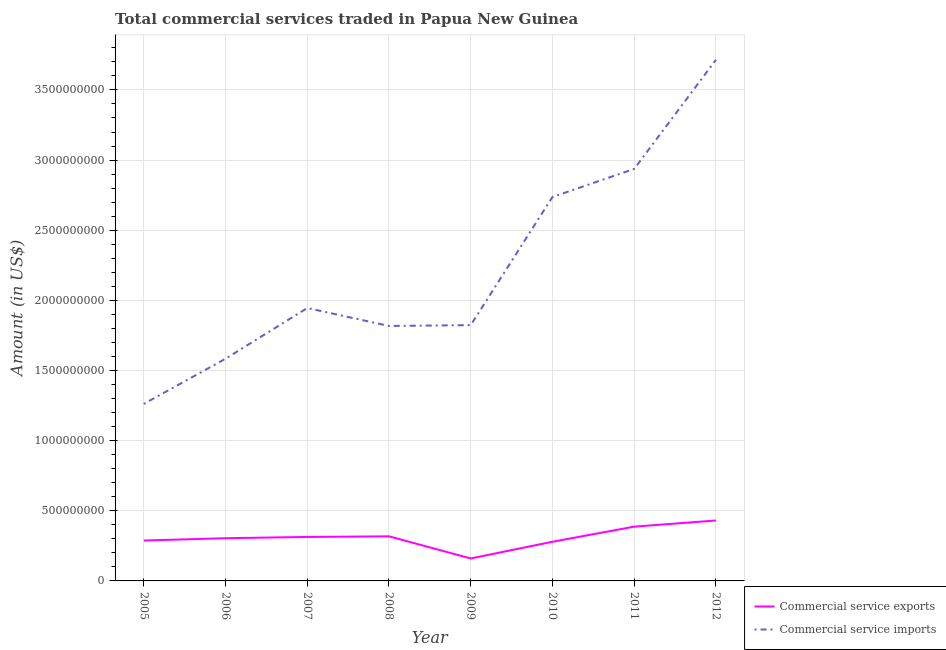How many different coloured lines are there?
Offer a terse response. 2. Does the line corresponding to amount of commercial service exports intersect with the line corresponding to amount of commercial service imports?
Offer a terse response. No. Is the number of lines equal to the number of legend labels?
Give a very brief answer. Yes. What is the amount of commercial service imports in 2006?
Your answer should be compact. 1.58e+09. Across all years, what is the maximum amount of commercial service exports?
Make the answer very short. 4.31e+08. Across all years, what is the minimum amount of commercial service exports?
Offer a terse response. 1.60e+08. In which year was the amount of commercial service imports maximum?
Provide a succinct answer. 2012. What is the total amount of commercial service exports in the graph?
Make the answer very short. 2.48e+09. What is the difference between the amount of commercial service exports in 2005 and that in 2010?
Make the answer very short. 8.80e+06. What is the difference between the amount of commercial service exports in 2012 and the amount of commercial service imports in 2009?
Your answer should be compact. -1.39e+09. What is the average amount of commercial service exports per year?
Your answer should be compact. 3.10e+08. In the year 2011, what is the difference between the amount of commercial service imports and amount of commercial service exports?
Keep it short and to the point. 2.55e+09. What is the ratio of the amount of commercial service imports in 2009 to that in 2010?
Make the answer very short. 0.67. Is the difference between the amount of commercial service exports in 2006 and 2007 greater than the difference between the amount of commercial service imports in 2006 and 2007?
Provide a short and direct response. Yes. What is the difference between the highest and the second highest amount of commercial service imports?
Keep it short and to the point. 7.78e+08. What is the difference between the highest and the lowest amount of commercial service imports?
Your answer should be very brief. 2.45e+09. In how many years, is the amount of commercial service exports greater than the average amount of commercial service exports taken over all years?
Your answer should be compact. 4. Is the sum of the amount of commercial service imports in 2006 and 2007 greater than the maximum amount of commercial service exports across all years?
Your answer should be very brief. Yes. Does the amount of commercial service exports monotonically increase over the years?
Your answer should be very brief. No. Is the amount of commercial service exports strictly greater than the amount of commercial service imports over the years?
Provide a succinct answer. No. How many years are there in the graph?
Your response must be concise. 8. What is the difference between two consecutive major ticks on the Y-axis?
Offer a terse response. 5.00e+08. Are the values on the major ticks of Y-axis written in scientific E-notation?
Offer a very short reply. No. How many legend labels are there?
Provide a succinct answer. 2. What is the title of the graph?
Provide a short and direct response. Total commercial services traded in Papua New Guinea. What is the label or title of the Y-axis?
Offer a terse response. Amount (in US$). What is the Amount (in US$) in Commercial service exports in 2005?
Provide a succinct answer. 2.88e+08. What is the Amount (in US$) in Commercial service imports in 2005?
Offer a terse response. 1.26e+09. What is the Amount (in US$) of Commercial service exports in 2006?
Your answer should be very brief. 3.05e+08. What is the Amount (in US$) in Commercial service imports in 2006?
Offer a very short reply. 1.58e+09. What is the Amount (in US$) of Commercial service exports in 2007?
Your answer should be compact. 3.13e+08. What is the Amount (in US$) in Commercial service imports in 2007?
Your answer should be compact. 1.95e+09. What is the Amount (in US$) in Commercial service exports in 2008?
Provide a succinct answer. 3.18e+08. What is the Amount (in US$) in Commercial service imports in 2008?
Make the answer very short. 1.82e+09. What is the Amount (in US$) in Commercial service exports in 2009?
Offer a very short reply. 1.60e+08. What is the Amount (in US$) in Commercial service imports in 2009?
Offer a terse response. 1.82e+09. What is the Amount (in US$) of Commercial service exports in 2010?
Your response must be concise. 2.79e+08. What is the Amount (in US$) in Commercial service imports in 2010?
Give a very brief answer. 2.74e+09. What is the Amount (in US$) of Commercial service exports in 2011?
Your answer should be very brief. 3.87e+08. What is the Amount (in US$) in Commercial service imports in 2011?
Your response must be concise. 2.94e+09. What is the Amount (in US$) in Commercial service exports in 2012?
Provide a succinct answer. 4.31e+08. What is the Amount (in US$) in Commercial service imports in 2012?
Your answer should be very brief. 3.71e+09. Across all years, what is the maximum Amount (in US$) of Commercial service exports?
Offer a very short reply. 4.31e+08. Across all years, what is the maximum Amount (in US$) of Commercial service imports?
Keep it short and to the point. 3.71e+09. Across all years, what is the minimum Amount (in US$) in Commercial service exports?
Keep it short and to the point. 1.60e+08. Across all years, what is the minimum Amount (in US$) in Commercial service imports?
Make the answer very short. 1.26e+09. What is the total Amount (in US$) of Commercial service exports in the graph?
Keep it short and to the point. 2.48e+09. What is the total Amount (in US$) in Commercial service imports in the graph?
Provide a short and direct response. 1.78e+1. What is the difference between the Amount (in US$) of Commercial service exports in 2005 and that in 2006?
Make the answer very short. -1.66e+07. What is the difference between the Amount (in US$) in Commercial service imports in 2005 and that in 2006?
Provide a succinct answer. -3.22e+08. What is the difference between the Amount (in US$) of Commercial service exports in 2005 and that in 2007?
Provide a short and direct response. -2.55e+07. What is the difference between the Amount (in US$) in Commercial service imports in 2005 and that in 2007?
Offer a terse response. -6.83e+08. What is the difference between the Amount (in US$) in Commercial service exports in 2005 and that in 2008?
Keep it short and to the point. -3.00e+07. What is the difference between the Amount (in US$) in Commercial service imports in 2005 and that in 2008?
Give a very brief answer. -5.56e+08. What is the difference between the Amount (in US$) of Commercial service exports in 2005 and that in 2009?
Your response must be concise. 1.28e+08. What is the difference between the Amount (in US$) of Commercial service imports in 2005 and that in 2009?
Make the answer very short. -5.62e+08. What is the difference between the Amount (in US$) in Commercial service exports in 2005 and that in 2010?
Provide a succinct answer. 8.80e+06. What is the difference between the Amount (in US$) of Commercial service imports in 2005 and that in 2010?
Provide a succinct answer. -1.48e+09. What is the difference between the Amount (in US$) of Commercial service exports in 2005 and that in 2011?
Offer a very short reply. -9.90e+07. What is the difference between the Amount (in US$) in Commercial service imports in 2005 and that in 2011?
Your answer should be compact. -1.68e+09. What is the difference between the Amount (in US$) in Commercial service exports in 2005 and that in 2012?
Give a very brief answer. -1.43e+08. What is the difference between the Amount (in US$) in Commercial service imports in 2005 and that in 2012?
Offer a very short reply. -2.45e+09. What is the difference between the Amount (in US$) in Commercial service exports in 2006 and that in 2007?
Offer a terse response. -8.85e+06. What is the difference between the Amount (in US$) of Commercial service imports in 2006 and that in 2007?
Keep it short and to the point. -3.61e+08. What is the difference between the Amount (in US$) of Commercial service exports in 2006 and that in 2008?
Offer a very short reply. -1.34e+07. What is the difference between the Amount (in US$) of Commercial service imports in 2006 and that in 2008?
Keep it short and to the point. -2.34e+08. What is the difference between the Amount (in US$) of Commercial service exports in 2006 and that in 2009?
Provide a succinct answer. 1.44e+08. What is the difference between the Amount (in US$) in Commercial service imports in 2006 and that in 2009?
Offer a very short reply. -2.40e+08. What is the difference between the Amount (in US$) of Commercial service exports in 2006 and that in 2010?
Offer a very short reply. 2.54e+07. What is the difference between the Amount (in US$) in Commercial service imports in 2006 and that in 2010?
Your answer should be very brief. -1.15e+09. What is the difference between the Amount (in US$) in Commercial service exports in 2006 and that in 2011?
Give a very brief answer. -8.23e+07. What is the difference between the Amount (in US$) in Commercial service imports in 2006 and that in 2011?
Give a very brief answer. -1.35e+09. What is the difference between the Amount (in US$) of Commercial service exports in 2006 and that in 2012?
Your response must be concise. -1.26e+08. What is the difference between the Amount (in US$) of Commercial service imports in 2006 and that in 2012?
Offer a terse response. -2.13e+09. What is the difference between the Amount (in US$) of Commercial service exports in 2007 and that in 2008?
Offer a terse response. -4.53e+06. What is the difference between the Amount (in US$) in Commercial service imports in 2007 and that in 2008?
Provide a succinct answer. 1.28e+08. What is the difference between the Amount (in US$) of Commercial service exports in 2007 and that in 2009?
Ensure brevity in your answer.  1.53e+08. What is the difference between the Amount (in US$) in Commercial service imports in 2007 and that in 2009?
Your answer should be compact. 1.22e+08. What is the difference between the Amount (in US$) in Commercial service exports in 2007 and that in 2010?
Provide a succinct answer. 3.43e+07. What is the difference between the Amount (in US$) of Commercial service imports in 2007 and that in 2010?
Your answer should be compact. -7.92e+08. What is the difference between the Amount (in US$) of Commercial service exports in 2007 and that in 2011?
Your answer should be very brief. -7.35e+07. What is the difference between the Amount (in US$) in Commercial service imports in 2007 and that in 2011?
Provide a succinct answer. -9.92e+08. What is the difference between the Amount (in US$) in Commercial service exports in 2007 and that in 2012?
Your answer should be compact. -1.17e+08. What is the difference between the Amount (in US$) of Commercial service imports in 2007 and that in 2012?
Provide a short and direct response. -1.77e+09. What is the difference between the Amount (in US$) of Commercial service exports in 2008 and that in 2009?
Make the answer very short. 1.58e+08. What is the difference between the Amount (in US$) of Commercial service imports in 2008 and that in 2009?
Ensure brevity in your answer.  -5.82e+06. What is the difference between the Amount (in US$) of Commercial service exports in 2008 and that in 2010?
Offer a terse response. 3.88e+07. What is the difference between the Amount (in US$) in Commercial service imports in 2008 and that in 2010?
Provide a succinct answer. -9.19e+08. What is the difference between the Amount (in US$) of Commercial service exports in 2008 and that in 2011?
Provide a succinct answer. -6.90e+07. What is the difference between the Amount (in US$) of Commercial service imports in 2008 and that in 2011?
Your response must be concise. -1.12e+09. What is the difference between the Amount (in US$) of Commercial service exports in 2008 and that in 2012?
Offer a terse response. -1.13e+08. What is the difference between the Amount (in US$) of Commercial service imports in 2008 and that in 2012?
Provide a short and direct response. -1.90e+09. What is the difference between the Amount (in US$) of Commercial service exports in 2009 and that in 2010?
Keep it short and to the point. -1.19e+08. What is the difference between the Amount (in US$) of Commercial service imports in 2009 and that in 2010?
Make the answer very short. -9.14e+08. What is the difference between the Amount (in US$) of Commercial service exports in 2009 and that in 2011?
Provide a short and direct response. -2.27e+08. What is the difference between the Amount (in US$) of Commercial service imports in 2009 and that in 2011?
Ensure brevity in your answer.  -1.11e+09. What is the difference between the Amount (in US$) of Commercial service exports in 2009 and that in 2012?
Keep it short and to the point. -2.71e+08. What is the difference between the Amount (in US$) in Commercial service imports in 2009 and that in 2012?
Provide a short and direct response. -1.89e+09. What is the difference between the Amount (in US$) of Commercial service exports in 2010 and that in 2011?
Your answer should be very brief. -1.08e+08. What is the difference between the Amount (in US$) of Commercial service imports in 2010 and that in 2011?
Provide a succinct answer. -2.00e+08. What is the difference between the Amount (in US$) in Commercial service exports in 2010 and that in 2012?
Provide a short and direct response. -1.52e+08. What is the difference between the Amount (in US$) of Commercial service imports in 2010 and that in 2012?
Offer a terse response. -9.78e+08. What is the difference between the Amount (in US$) in Commercial service exports in 2011 and that in 2012?
Your answer should be very brief. -4.38e+07. What is the difference between the Amount (in US$) of Commercial service imports in 2011 and that in 2012?
Offer a very short reply. -7.78e+08. What is the difference between the Amount (in US$) of Commercial service exports in 2005 and the Amount (in US$) of Commercial service imports in 2006?
Ensure brevity in your answer.  -1.30e+09. What is the difference between the Amount (in US$) in Commercial service exports in 2005 and the Amount (in US$) in Commercial service imports in 2007?
Your answer should be compact. -1.66e+09. What is the difference between the Amount (in US$) in Commercial service exports in 2005 and the Amount (in US$) in Commercial service imports in 2008?
Provide a short and direct response. -1.53e+09. What is the difference between the Amount (in US$) in Commercial service exports in 2005 and the Amount (in US$) in Commercial service imports in 2009?
Your response must be concise. -1.54e+09. What is the difference between the Amount (in US$) in Commercial service exports in 2005 and the Amount (in US$) in Commercial service imports in 2010?
Give a very brief answer. -2.45e+09. What is the difference between the Amount (in US$) in Commercial service exports in 2005 and the Amount (in US$) in Commercial service imports in 2011?
Your answer should be compact. -2.65e+09. What is the difference between the Amount (in US$) in Commercial service exports in 2005 and the Amount (in US$) in Commercial service imports in 2012?
Keep it short and to the point. -3.43e+09. What is the difference between the Amount (in US$) of Commercial service exports in 2006 and the Amount (in US$) of Commercial service imports in 2007?
Ensure brevity in your answer.  -1.64e+09. What is the difference between the Amount (in US$) of Commercial service exports in 2006 and the Amount (in US$) of Commercial service imports in 2008?
Keep it short and to the point. -1.51e+09. What is the difference between the Amount (in US$) in Commercial service exports in 2006 and the Amount (in US$) in Commercial service imports in 2009?
Your answer should be compact. -1.52e+09. What is the difference between the Amount (in US$) of Commercial service exports in 2006 and the Amount (in US$) of Commercial service imports in 2010?
Your answer should be very brief. -2.43e+09. What is the difference between the Amount (in US$) of Commercial service exports in 2006 and the Amount (in US$) of Commercial service imports in 2011?
Your answer should be very brief. -2.63e+09. What is the difference between the Amount (in US$) of Commercial service exports in 2006 and the Amount (in US$) of Commercial service imports in 2012?
Your answer should be compact. -3.41e+09. What is the difference between the Amount (in US$) of Commercial service exports in 2007 and the Amount (in US$) of Commercial service imports in 2008?
Provide a short and direct response. -1.50e+09. What is the difference between the Amount (in US$) in Commercial service exports in 2007 and the Amount (in US$) in Commercial service imports in 2009?
Make the answer very short. -1.51e+09. What is the difference between the Amount (in US$) in Commercial service exports in 2007 and the Amount (in US$) in Commercial service imports in 2010?
Ensure brevity in your answer.  -2.42e+09. What is the difference between the Amount (in US$) in Commercial service exports in 2007 and the Amount (in US$) in Commercial service imports in 2011?
Keep it short and to the point. -2.62e+09. What is the difference between the Amount (in US$) of Commercial service exports in 2007 and the Amount (in US$) of Commercial service imports in 2012?
Give a very brief answer. -3.40e+09. What is the difference between the Amount (in US$) in Commercial service exports in 2008 and the Amount (in US$) in Commercial service imports in 2009?
Ensure brevity in your answer.  -1.51e+09. What is the difference between the Amount (in US$) in Commercial service exports in 2008 and the Amount (in US$) in Commercial service imports in 2010?
Your answer should be very brief. -2.42e+09. What is the difference between the Amount (in US$) of Commercial service exports in 2008 and the Amount (in US$) of Commercial service imports in 2011?
Provide a succinct answer. -2.62e+09. What is the difference between the Amount (in US$) of Commercial service exports in 2008 and the Amount (in US$) of Commercial service imports in 2012?
Ensure brevity in your answer.  -3.40e+09. What is the difference between the Amount (in US$) of Commercial service exports in 2009 and the Amount (in US$) of Commercial service imports in 2010?
Your response must be concise. -2.58e+09. What is the difference between the Amount (in US$) in Commercial service exports in 2009 and the Amount (in US$) in Commercial service imports in 2011?
Your answer should be compact. -2.78e+09. What is the difference between the Amount (in US$) of Commercial service exports in 2009 and the Amount (in US$) of Commercial service imports in 2012?
Give a very brief answer. -3.55e+09. What is the difference between the Amount (in US$) of Commercial service exports in 2010 and the Amount (in US$) of Commercial service imports in 2011?
Provide a short and direct response. -2.66e+09. What is the difference between the Amount (in US$) in Commercial service exports in 2010 and the Amount (in US$) in Commercial service imports in 2012?
Provide a succinct answer. -3.44e+09. What is the difference between the Amount (in US$) of Commercial service exports in 2011 and the Amount (in US$) of Commercial service imports in 2012?
Give a very brief answer. -3.33e+09. What is the average Amount (in US$) of Commercial service exports per year?
Offer a very short reply. 3.10e+08. What is the average Amount (in US$) in Commercial service imports per year?
Offer a terse response. 2.23e+09. In the year 2005, what is the difference between the Amount (in US$) in Commercial service exports and Amount (in US$) in Commercial service imports?
Provide a succinct answer. -9.74e+08. In the year 2006, what is the difference between the Amount (in US$) of Commercial service exports and Amount (in US$) of Commercial service imports?
Ensure brevity in your answer.  -1.28e+09. In the year 2007, what is the difference between the Amount (in US$) in Commercial service exports and Amount (in US$) in Commercial service imports?
Ensure brevity in your answer.  -1.63e+09. In the year 2008, what is the difference between the Amount (in US$) of Commercial service exports and Amount (in US$) of Commercial service imports?
Give a very brief answer. -1.50e+09. In the year 2009, what is the difference between the Amount (in US$) in Commercial service exports and Amount (in US$) in Commercial service imports?
Your response must be concise. -1.66e+09. In the year 2010, what is the difference between the Amount (in US$) in Commercial service exports and Amount (in US$) in Commercial service imports?
Make the answer very short. -2.46e+09. In the year 2011, what is the difference between the Amount (in US$) in Commercial service exports and Amount (in US$) in Commercial service imports?
Keep it short and to the point. -2.55e+09. In the year 2012, what is the difference between the Amount (in US$) in Commercial service exports and Amount (in US$) in Commercial service imports?
Keep it short and to the point. -3.28e+09. What is the ratio of the Amount (in US$) of Commercial service exports in 2005 to that in 2006?
Give a very brief answer. 0.95. What is the ratio of the Amount (in US$) in Commercial service imports in 2005 to that in 2006?
Your answer should be very brief. 0.8. What is the ratio of the Amount (in US$) in Commercial service exports in 2005 to that in 2007?
Offer a terse response. 0.92. What is the ratio of the Amount (in US$) of Commercial service imports in 2005 to that in 2007?
Make the answer very short. 0.65. What is the ratio of the Amount (in US$) in Commercial service exports in 2005 to that in 2008?
Your answer should be very brief. 0.91. What is the ratio of the Amount (in US$) in Commercial service imports in 2005 to that in 2008?
Your answer should be compact. 0.69. What is the ratio of the Amount (in US$) in Commercial service exports in 2005 to that in 2009?
Give a very brief answer. 1.8. What is the ratio of the Amount (in US$) of Commercial service imports in 2005 to that in 2009?
Your answer should be very brief. 0.69. What is the ratio of the Amount (in US$) in Commercial service exports in 2005 to that in 2010?
Make the answer very short. 1.03. What is the ratio of the Amount (in US$) in Commercial service imports in 2005 to that in 2010?
Ensure brevity in your answer.  0.46. What is the ratio of the Amount (in US$) in Commercial service exports in 2005 to that in 2011?
Make the answer very short. 0.74. What is the ratio of the Amount (in US$) in Commercial service imports in 2005 to that in 2011?
Provide a short and direct response. 0.43. What is the ratio of the Amount (in US$) of Commercial service exports in 2005 to that in 2012?
Your answer should be very brief. 0.67. What is the ratio of the Amount (in US$) of Commercial service imports in 2005 to that in 2012?
Give a very brief answer. 0.34. What is the ratio of the Amount (in US$) in Commercial service exports in 2006 to that in 2007?
Provide a short and direct response. 0.97. What is the ratio of the Amount (in US$) of Commercial service imports in 2006 to that in 2007?
Offer a very short reply. 0.81. What is the ratio of the Amount (in US$) in Commercial service exports in 2006 to that in 2008?
Offer a terse response. 0.96. What is the ratio of the Amount (in US$) of Commercial service imports in 2006 to that in 2008?
Your answer should be compact. 0.87. What is the ratio of the Amount (in US$) in Commercial service exports in 2006 to that in 2009?
Ensure brevity in your answer.  1.9. What is the ratio of the Amount (in US$) of Commercial service imports in 2006 to that in 2009?
Give a very brief answer. 0.87. What is the ratio of the Amount (in US$) in Commercial service exports in 2006 to that in 2010?
Provide a short and direct response. 1.09. What is the ratio of the Amount (in US$) of Commercial service imports in 2006 to that in 2010?
Give a very brief answer. 0.58. What is the ratio of the Amount (in US$) of Commercial service exports in 2006 to that in 2011?
Your answer should be very brief. 0.79. What is the ratio of the Amount (in US$) in Commercial service imports in 2006 to that in 2011?
Your response must be concise. 0.54. What is the ratio of the Amount (in US$) of Commercial service exports in 2006 to that in 2012?
Keep it short and to the point. 0.71. What is the ratio of the Amount (in US$) of Commercial service imports in 2006 to that in 2012?
Make the answer very short. 0.43. What is the ratio of the Amount (in US$) of Commercial service exports in 2007 to that in 2008?
Offer a very short reply. 0.99. What is the ratio of the Amount (in US$) in Commercial service imports in 2007 to that in 2008?
Provide a short and direct response. 1.07. What is the ratio of the Amount (in US$) in Commercial service exports in 2007 to that in 2009?
Keep it short and to the point. 1.96. What is the ratio of the Amount (in US$) in Commercial service imports in 2007 to that in 2009?
Ensure brevity in your answer.  1.07. What is the ratio of the Amount (in US$) of Commercial service exports in 2007 to that in 2010?
Provide a succinct answer. 1.12. What is the ratio of the Amount (in US$) in Commercial service imports in 2007 to that in 2010?
Offer a very short reply. 0.71. What is the ratio of the Amount (in US$) in Commercial service exports in 2007 to that in 2011?
Provide a short and direct response. 0.81. What is the ratio of the Amount (in US$) in Commercial service imports in 2007 to that in 2011?
Your response must be concise. 0.66. What is the ratio of the Amount (in US$) of Commercial service exports in 2007 to that in 2012?
Make the answer very short. 0.73. What is the ratio of the Amount (in US$) of Commercial service imports in 2007 to that in 2012?
Make the answer very short. 0.52. What is the ratio of the Amount (in US$) in Commercial service exports in 2008 to that in 2009?
Make the answer very short. 1.99. What is the ratio of the Amount (in US$) in Commercial service exports in 2008 to that in 2010?
Ensure brevity in your answer.  1.14. What is the ratio of the Amount (in US$) in Commercial service imports in 2008 to that in 2010?
Provide a short and direct response. 0.66. What is the ratio of the Amount (in US$) of Commercial service exports in 2008 to that in 2011?
Your response must be concise. 0.82. What is the ratio of the Amount (in US$) of Commercial service imports in 2008 to that in 2011?
Provide a short and direct response. 0.62. What is the ratio of the Amount (in US$) in Commercial service exports in 2008 to that in 2012?
Make the answer very short. 0.74. What is the ratio of the Amount (in US$) in Commercial service imports in 2008 to that in 2012?
Ensure brevity in your answer.  0.49. What is the ratio of the Amount (in US$) in Commercial service exports in 2009 to that in 2010?
Provide a succinct answer. 0.57. What is the ratio of the Amount (in US$) of Commercial service imports in 2009 to that in 2010?
Ensure brevity in your answer.  0.67. What is the ratio of the Amount (in US$) of Commercial service exports in 2009 to that in 2011?
Provide a succinct answer. 0.41. What is the ratio of the Amount (in US$) in Commercial service imports in 2009 to that in 2011?
Keep it short and to the point. 0.62. What is the ratio of the Amount (in US$) of Commercial service exports in 2009 to that in 2012?
Make the answer very short. 0.37. What is the ratio of the Amount (in US$) of Commercial service imports in 2009 to that in 2012?
Your answer should be compact. 0.49. What is the ratio of the Amount (in US$) in Commercial service exports in 2010 to that in 2011?
Your response must be concise. 0.72. What is the ratio of the Amount (in US$) in Commercial service imports in 2010 to that in 2011?
Your response must be concise. 0.93. What is the ratio of the Amount (in US$) in Commercial service exports in 2010 to that in 2012?
Keep it short and to the point. 0.65. What is the ratio of the Amount (in US$) of Commercial service imports in 2010 to that in 2012?
Ensure brevity in your answer.  0.74. What is the ratio of the Amount (in US$) of Commercial service exports in 2011 to that in 2012?
Give a very brief answer. 0.9. What is the ratio of the Amount (in US$) in Commercial service imports in 2011 to that in 2012?
Provide a succinct answer. 0.79. What is the difference between the highest and the second highest Amount (in US$) of Commercial service exports?
Your answer should be compact. 4.38e+07. What is the difference between the highest and the second highest Amount (in US$) of Commercial service imports?
Give a very brief answer. 7.78e+08. What is the difference between the highest and the lowest Amount (in US$) in Commercial service exports?
Provide a succinct answer. 2.71e+08. What is the difference between the highest and the lowest Amount (in US$) in Commercial service imports?
Ensure brevity in your answer.  2.45e+09. 